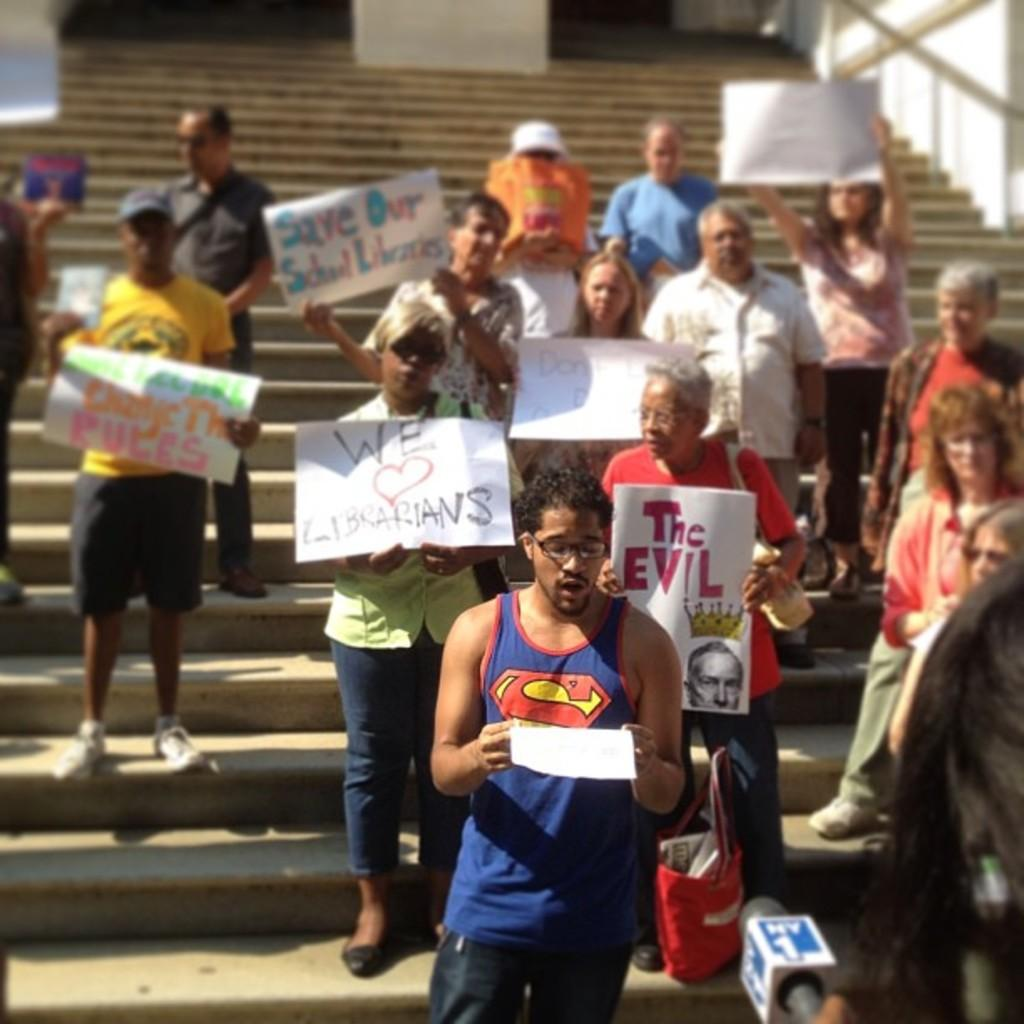What are the people in the image doing? There is a group of people standing on the stairs, and they are holding papers. Can you describe the person in the image who is not holding papers? There is a person holding a microphone. What can be seen in the background of the image? There is a building in the background. What type of wing can be seen on the person holding the microphone in the image? There is no wing visible on the person holding the microphone in the image. What direction is the zephyr blowing in the image? There is no mention of a zephyr or any wind in the image. 